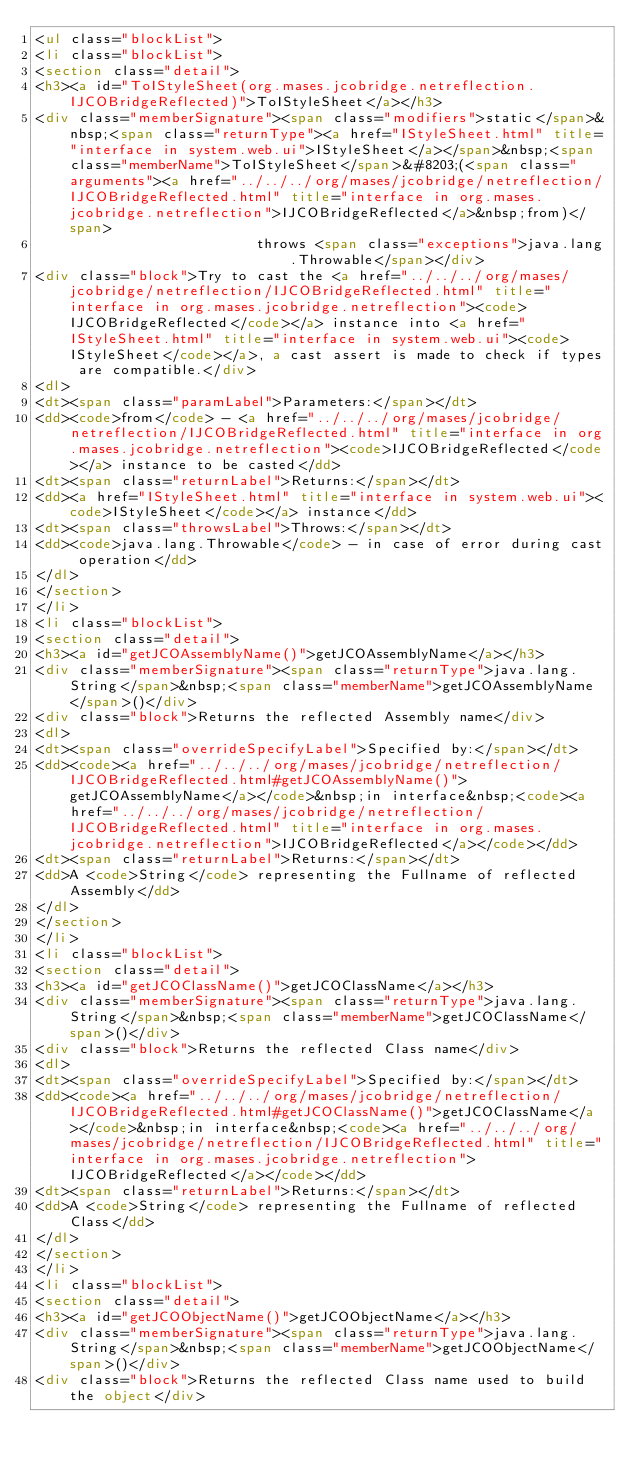Convert code to text. <code><loc_0><loc_0><loc_500><loc_500><_HTML_><ul class="blockList">
<li class="blockList">
<section class="detail">
<h3><a id="ToIStyleSheet(org.mases.jcobridge.netreflection.IJCOBridgeReflected)">ToIStyleSheet</a></h3>
<div class="memberSignature"><span class="modifiers">static</span>&nbsp;<span class="returnType"><a href="IStyleSheet.html" title="interface in system.web.ui">IStyleSheet</a></span>&nbsp;<span class="memberName">ToIStyleSheet</span>&#8203;(<span class="arguments"><a href="../../../org/mases/jcobridge/netreflection/IJCOBridgeReflected.html" title="interface in org.mases.jcobridge.netreflection">IJCOBridgeReflected</a>&nbsp;from)</span>
                          throws <span class="exceptions">java.lang.Throwable</span></div>
<div class="block">Try to cast the <a href="../../../org/mases/jcobridge/netreflection/IJCOBridgeReflected.html" title="interface in org.mases.jcobridge.netreflection"><code>IJCOBridgeReflected</code></a> instance into <a href="IStyleSheet.html" title="interface in system.web.ui"><code>IStyleSheet</code></a>, a cast assert is made to check if types are compatible.</div>
<dl>
<dt><span class="paramLabel">Parameters:</span></dt>
<dd><code>from</code> - <a href="../../../org/mases/jcobridge/netreflection/IJCOBridgeReflected.html" title="interface in org.mases.jcobridge.netreflection"><code>IJCOBridgeReflected</code></a> instance to be casted</dd>
<dt><span class="returnLabel">Returns:</span></dt>
<dd><a href="IStyleSheet.html" title="interface in system.web.ui"><code>IStyleSheet</code></a> instance</dd>
<dt><span class="throwsLabel">Throws:</span></dt>
<dd><code>java.lang.Throwable</code> - in case of error during cast operation</dd>
</dl>
</section>
</li>
<li class="blockList">
<section class="detail">
<h3><a id="getJCOAssemblyName()">getJCOAssemblyName</a></h3>
<div class="memberSignature"><span class="returnType">java.lang.String</span>&nbsp;<span class="memberName">getJCOAssemblyName</span>()</div>
<div class="block">Returns the reflected Assembly name</div>
<dl>
<dt><span class="overrideSpecifyLabel">Specified by:</span></dt>
<dd><code><a href="../../../org/mases/jcobridge/netreflection/IJCOBridgeReflected.html#getJCOAssemblyName()">getJCOAssemblyName</a></code>&nbsp;in interface&nbsp;<code><a href="../../../org/mases/jcobridge/netreflection/IJCOBridgeReflected.html" title="interface in org.mases.jcobridge.netreflection">IJCOBridgeReflected</a></code></dd>
<dt><span class="returnLabel">Returns:</span></dt>
<dd>A <code>String</code> representing the Fullname of reflected Assembly</dd>
</dl>
</section>
</li>
<li class="blockList">
<section class="detail">
<h3><a id="getJCOClassName()">getJCOClassName</a></h3>
<div class="memberSignature"><span class="returnType">java.lang.String</span>&nbsp;<span class="memberName">getJCOClassName</span>()</div>
<div class="block">Returns the reflected Class name</div>
<dl>
<dt><span class="overrideSpecifyLabel">Specified by:</span></dt>
<dd><code><a href="../../../org/mases/jcobridge/netreflection/IJCOBridgeReflected.html#getJCOClassName()">getJCOClassName</a></code>&nbsp;in interface&nbsp;<code><a href="../../../org/mases/jcobridge/netreflection/IJCOBridgeReflected.html" title="interface in org.mases.jcobridge.netreflection">IJCOBridgeReflected</a></code></dd>
<dt><span class="returnLabel">Returns:</span></dt>
<dd>A <code>String</code> representing the Fullname of reflected Class</dd>
</dl>
</section>
</li>
<li class="blockList">
<section class="detail">
<h3><a id="getJCOObjectName()">getJCOObjectName</a></h3>
<div class="memberSignature"><span class="returnType">java.lang.String</span>&nbsp;<span class="memberName">getJCOObjectName</span>()</div>
<div class="block">Returns the reflected Class name used to build the object</div></code> 